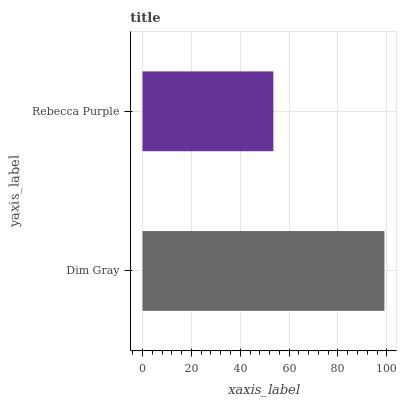Is Rebecca Purple the minimum?
Answer yes or no. Yes. Is Dim Gray the maximum?
Answer yes or no. Yes. Is Rebecca Purple the maximum?
Answer yes or no. No. Is Dim Gray greater than Rebecca Purple?
Answer yes or no. Yes. Is Rebecca Purple less than Dim Gray?
Answer yes or no. Yes. Is Rebecca Purple greater than Dim Gray?
Answer yes or no. No. Is Dim Gray less than Rebecca Purple?
Answer yes or no. No. Is Dim Gray the high median?
Answer yes or no. Yes. Is Rebecca Purple the low median?
Answer yes or no. Yes. Is Rebecca Purple the high median?
Answer yes or no. No. Is Dim Gray the low median?
Answer yes or no. No. 